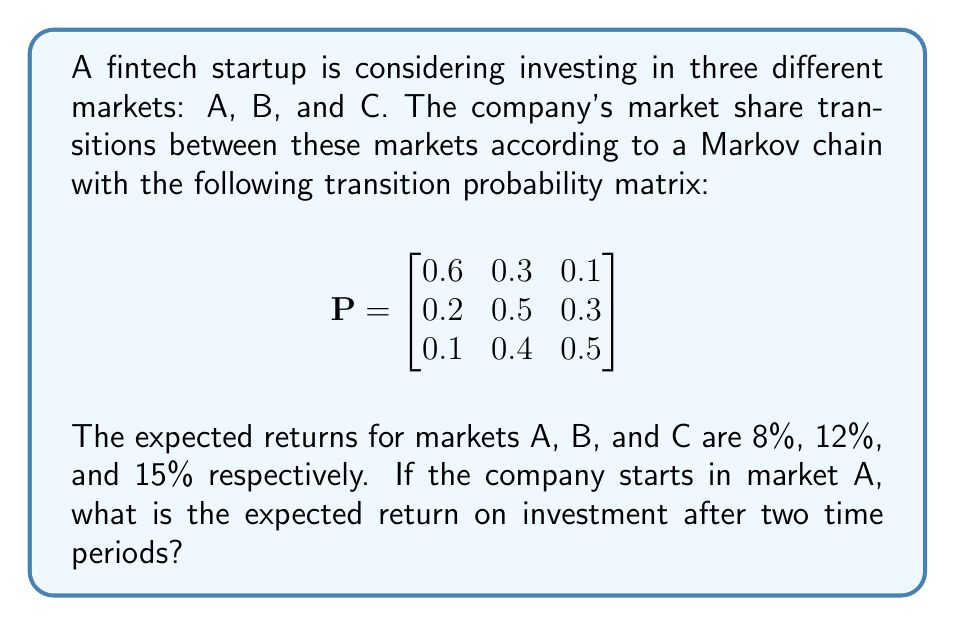Could you help me with this problem? To solve this problem, we'll follow these steps:

1. Calculate the probability distribution after two time periods:
   We start in market A, so our initial distribution is $\pi_0 = [1, 0, 0]$.
   After two time periods, the distribution will be $\pi_2 = \pi_0 P^2$.

   First, let's calculate $P^2$:
   $$P^2 = \begin{bmatrix}
   0.6 & 0.3 & 0.1 \\
   0.2 & 0.5 & 0.3 \\
   0.1 & 0.4 & 0.5
   \end{bmatrix} \times \begin{bmatrix}
   0.6 & 0.3 & 0.1 \\
   0.2 & 0.5 & 0.3 \\
   0.1 & 0.4 & 0.5
   \end{bmatrix}$$

   $$P^2 = \begin{bmatrix}
   0.42 & 0.39 & 0.19 \\
   0.23 & 0.46 & 0.31 \\
   0.17 & 0.43 & 0.40
   \end{bmatrix}$$

   Now, we can calculate $\pi_2$:
   $$\pi_2 = [1, 0, 0] \times \begin{bmatrix}
   0.42 & 0.39 & 0.19 \\
   0.23 & 0.46 & 0.31 \\
   0.17 & 0.43 & 0.40
   \end{bmatrix} = [0.42, 0.39, 0.19]$$

2. Calculate the expected return:
   The expected return is the sum of the probabilities of being in each market multiplied by the respective returns.

   $$E[R] = 0.42 \times 8\% + 0.39 \times 12\% + 0.19 \times 15\%$$
   $$E[R] = 0.0336 + 0.0468 + 0.0285 = 0.1089$$

3. Convert to percentage:
   $$E[R] = 0.1089 \times 100\% = 10.89\%$$

Therefore, the expected return on investment after two time periods is 10.89%.
Answer: 10.89% 